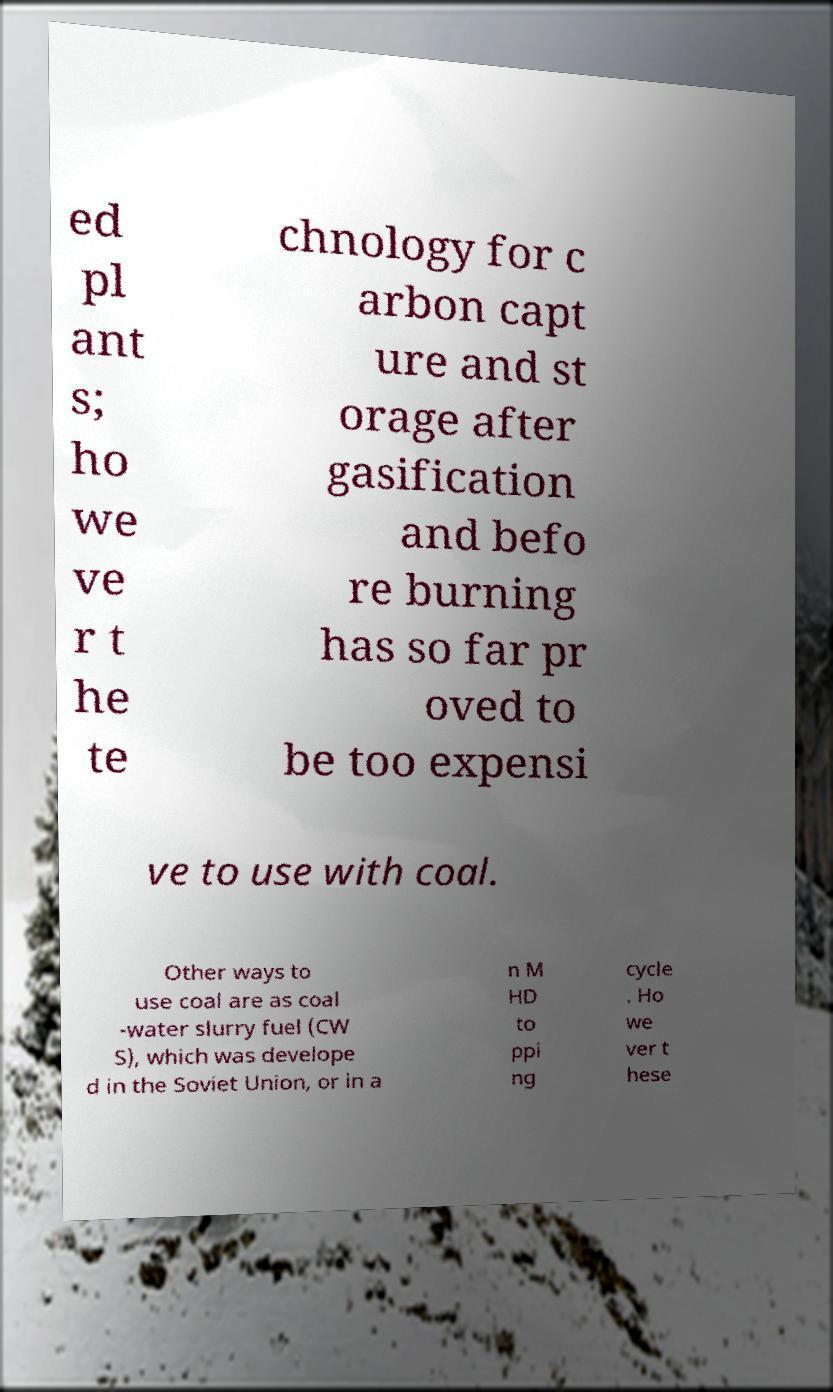There's text embedded in this image that I need extracted. Can you transcribe it verbatim? ed pl ant s; ho we ve r t he te chnology for c arbon capt ure and st orage after gasification and befo re burning has so far pr oved to be too expensi ve to use with coal. Other ways to use coal are as coal -water slurry fuel (CW S), which was develope d in the Soviet Union, or in a n M HD to ppi ng cycle . Ho we ver t hese 